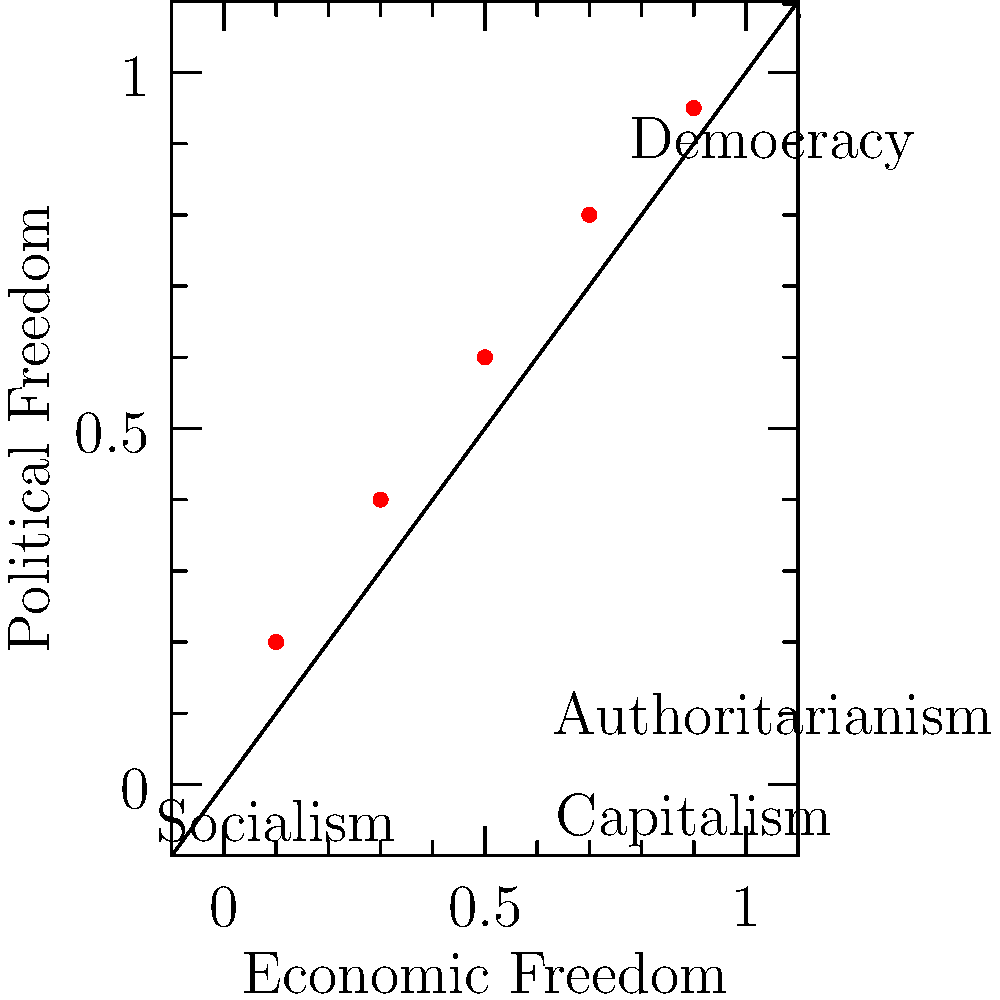Based on the scatter plot showing the relationship between economic freedom and political freedom, what conclusion can be drawn about the correlation between capitalist economic systems and democratic political ideologies? To answer this question, we need to analyze the scatter plot step-by-step:

1. The x-axis represents economic freedom, with capitalism on the right (0.9) and socialism on the left (0.1).
2. The y-axis represents political freedom, with democracy at the top (0.9) and authoritarianism at the bottom (0.1).
3. Each red dot on the plot represents a data point showing the relationship between economic and political freedom for different countries or systems.
4. Observing the pattern of the dots, we can see a clear positive correlation: as we move from left to right (increasing economic freedom), the dots tend to move upward (increasing political freedom).
5. This positive correlation suggests that countries with more capitalist economic systems (towards the right) tend to have more democratic political systems (towards the top).
6. Conversely, countries with more socialist economic systems (towards the left) tend to have more authoritarian political systems (towards the bottom).
7. The relationship appears to be roughly linear, indicating a consistent trend across the spectrum of economic systems.

Given this analysis, we can conclude that there is a strong positive correlation between capitalist economic systems and democratic political ideologies, as shown by the upward trend of the scatter plot from left to right.
Answer: Strong positive correlation 